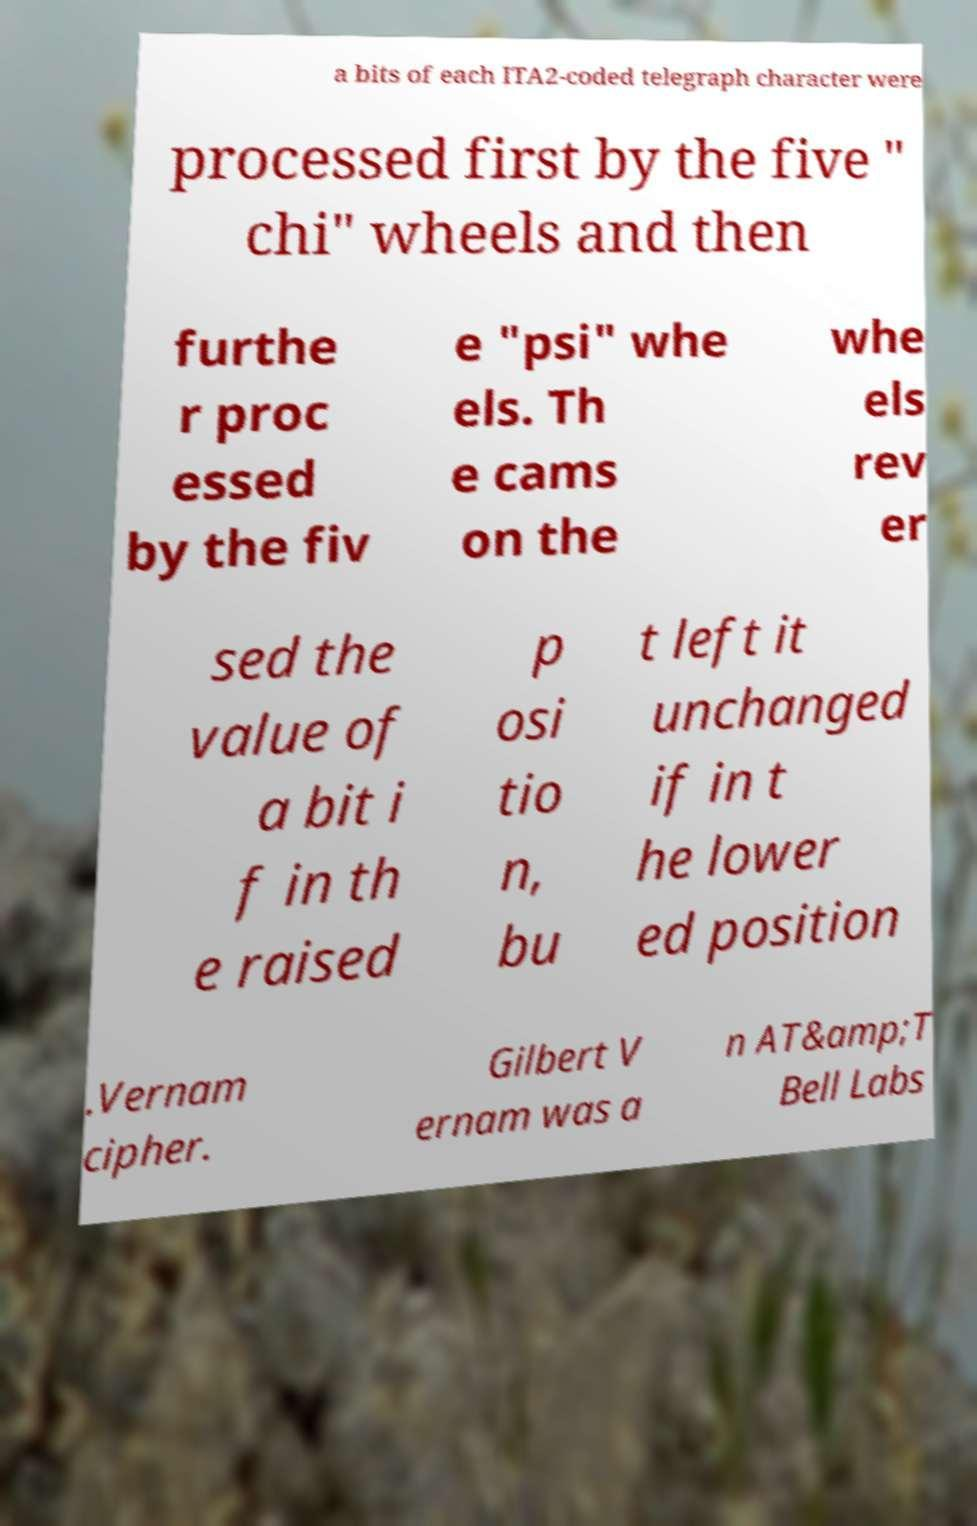There's text embedded in this image that I need extracted. Can you transcribe it verbatim? a bits of each ITA2-coded telegraph character were processed first by the five " chi" wheels and then furthe r proc essed by the fiv e "psi" whe els. Th e cams on the whe els rev er sed the value of a bit i f in th e raised p osi tio n, bu t left it unchanged if in t he lower ed position .Vernam cipher. Gilbert V ernam was a n AT&amp;T Bell Labs 